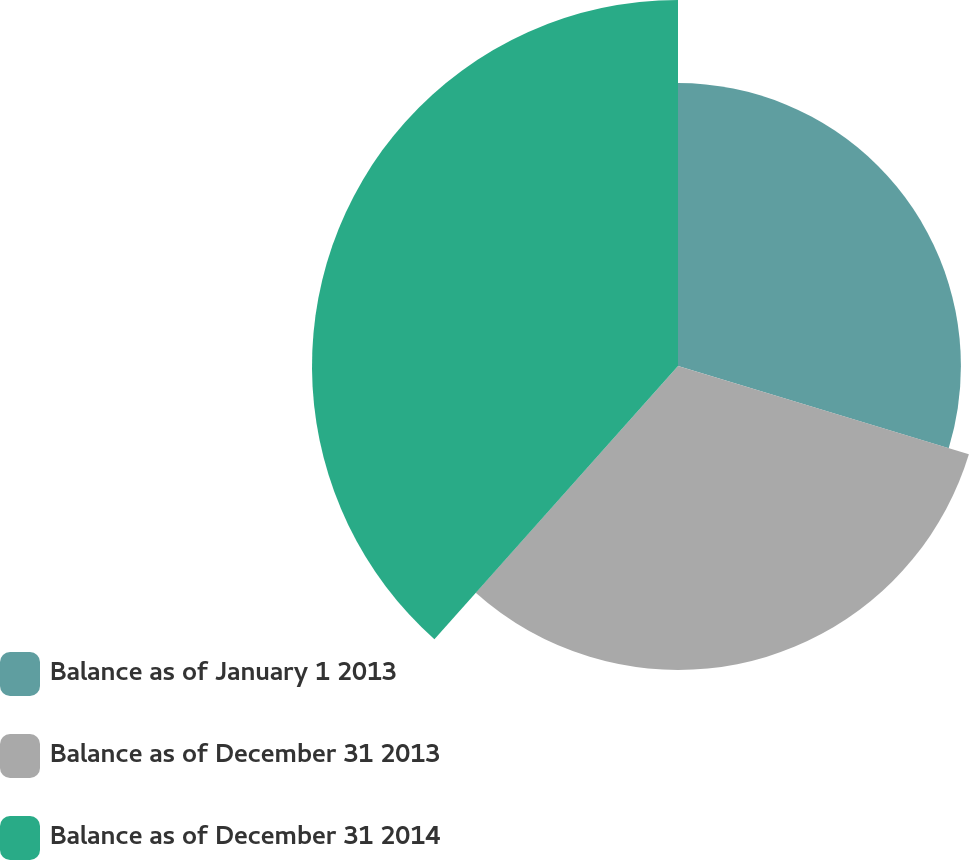<chart> <loc_0><loc_0><loc_500><loc_500><pie_chart><fcel>Balance as of January 1 2013<fcel>Balance as of December 31 2013<fcel>Balance as of December 31 2014<nl><fcel>29.69%<fcel>31.9%<fcel>38.41%<nl></chart> 